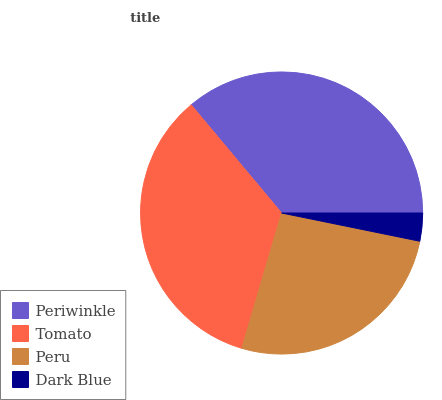Is Dark Blue the minimum?
Answer yes or no. Yes. Is Periwinkle the maximum?
Answer yes or no. Yes. Is Tomato the minimum?
Answer yes or no. No. Is Tomato the maximum?
Answer yes or no. No. Is Periwinkle greater than Tomato?
Answer yes or no. Yes. Is Tomato less than Periwinkle?
Answer yes or no. Yes. Is Tomato greater than Periwinkle?
Answer yes or no. No. Is Periwinkle less than Tomato?
Answer yes or no. No. Is Tomato the high median?
Answer yes or no. Yes. Is Peru the low median?
Answer yes or no. Yes. Is Periwinkle the high median?
Answer yes or no. No. Is Tomato the low median?
Answer yes or no. No. 